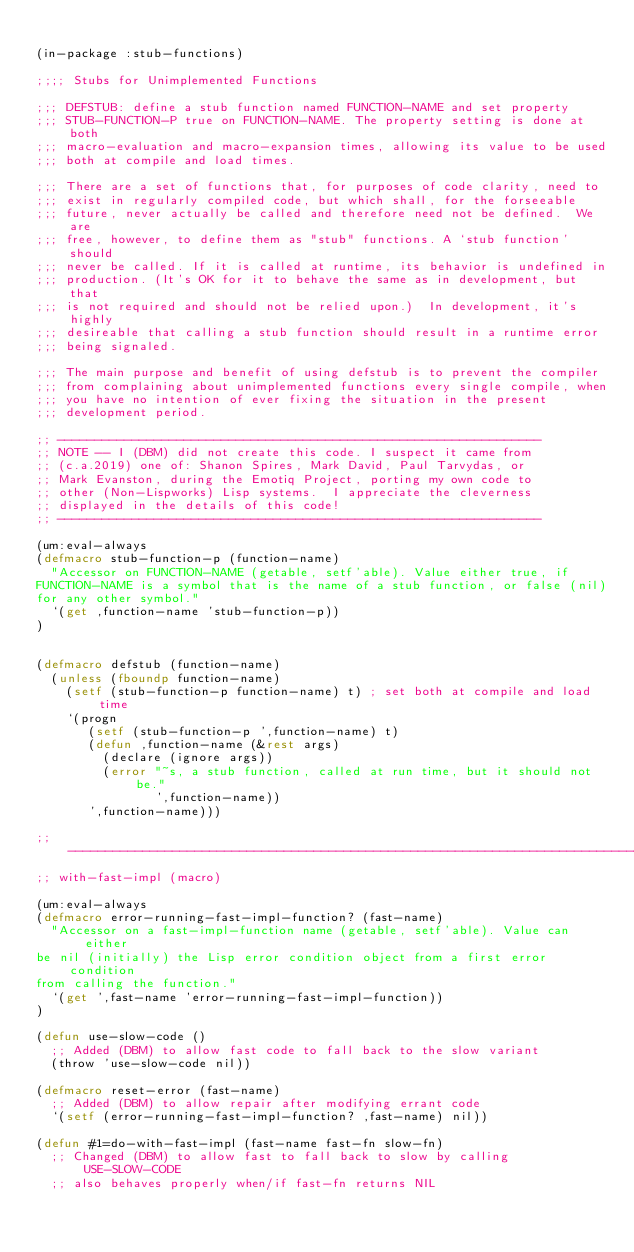<code> <loc_0><loc_0><loc_500><loc_500><_Lisp_>
(in-package :stub-functions)

;;;; Stubs for Unimplemented Functions

;;; DEFSTUB: define a stub function named FUNCTION-NAME and set property
;;; STUB-FUNCTION-P true on FUNCTION-NAME. The property setting is done at both
;;; macro-evaluation and macro-expansion times, allowing its value to be used
;;; both at compile and load times.

;;; There are a set of functions that, for purposes of code clarity, need to
;;; exist in regularly compiled code, but which shall, for the forseeable
;;; future, never actually be called and therefore need not be defined.  We are
;;; free, however, to define them as "stub" functions. A `stub function' should
;;; never be called. If it is called at runtime, its behavior is undefined in
;;; production. (It's OK for it to behave the same as in development, but that
;;; is not required and should not be relied upon.)  In development, it's highly
;;; desireable that calling a stub function should result in a runtime error
;;; being signaled.

;;; The main purpose and benefit of using defstub is to prevent the compiler
;;; from complaining about unimplemented functions every single compile, when
;;; you have no intention of ever fixing the situation in the present
;;; development period.

;; -----------------------------------------------------------------
;; NOTE -- I (DBM) did not create this code. I suspect it came from
;; (c.a.2019) one of: Shanon Spires, Mark David, Paul Tarvydas, or
;; Mark Evanston, during the Emotiq Project, porting my own code to
;; other (Non-Lispworks) Lisp systems.  I appreciate the cleverness
;; displayed in the details of this code!
;; -----------------------------------------------------------------

(um:eval-always
(defmacro stub-function-p (function-name)
  "Accessor on FUNCTION-NAME (getable, setf'able). Value either true, if
FUNCTION-NAME is a symbol that is the name of a stub function, or false (nil)
for any other symbol."
  `(get ,function-name 'stub-function-p))
)
  

(defmacro defstub (function-name)
  (unless (fboundp function-name)
    (setf (stub-function-p function-name) t) ; set both at compile and load time
    `(progn
       (setf (stub-function-p ',function-name) t)
       (defun ,function-name (&rest args)
         (declare (ignore args))
         (error "~s, a stub function, called at run time, but it should not be."
                ',function-name))
       ',function-name)))

;; -----------------------------------------------------------------------------
;; with-fast-impl (macro)

(um:eval-always
(defmacro error-running-fast-impl-function? (fast-name)
  "Accessor on a fast-impl-function name (getable, setf'able). Value can either
be nil (initially) the Lisp error condition object from a first error condition
from calling the function."
  `(get ',fast-name 'error-running-fast-impl-function))
)

(defun use-slow-code ()
  ;; Added (DBM) to allow fast code to fall back to the slow variant
  (throw 'use-slow-code nil))

(defmacro reset-error (fast-name)
  ;; Added (DBM) to allow repair after modifying errant code
  `(setf (error-running-fast-impl-function? ,fast-name) nil))

(defun #1=do-with-fast-impl (fast-name fast-fn slow-fn)
  ;; Changed (DBM) to allow fast to fall back to slow by calling USE-SLOW-CODE
  ;; also behaves properly when/if fast-fn returns NIL</code> 